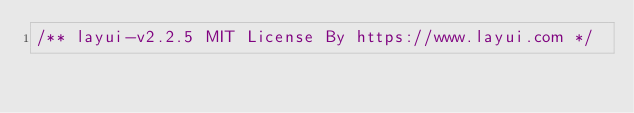Convert code to text. <code><loc_0><loc_0><loc_500><loc_500><_CSS_>/** layui-v2.2.5 MIT License By https://www.layui.com */</code> 